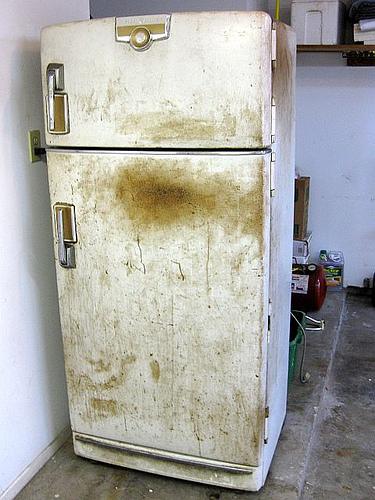Is the fridge dirty?
Keep it brief. Yes. Where is the refrigerator located?
Concise answer only. Garage. Is this a new fridge?
Give a very brief answer. No. 